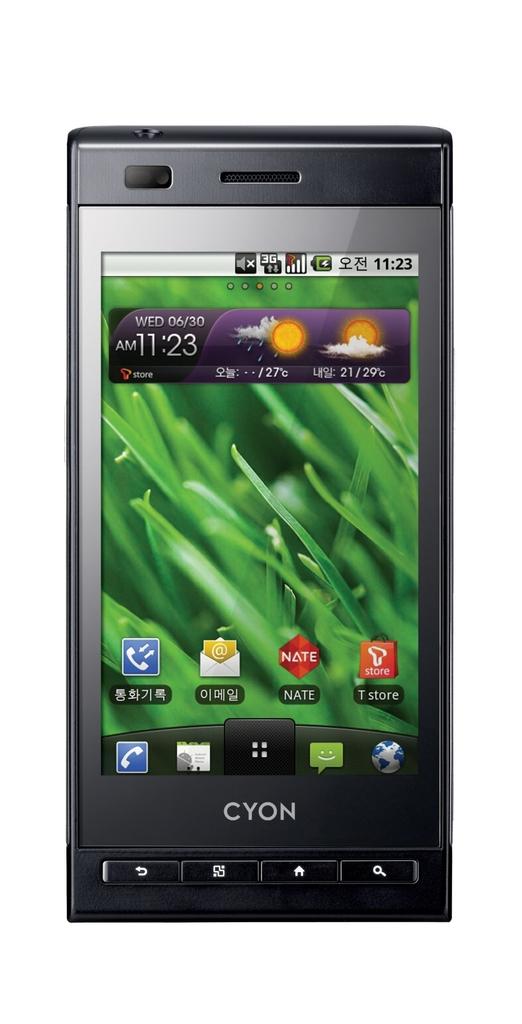What is the brand of the phone?
Keep it short and to the point. Cyon. 